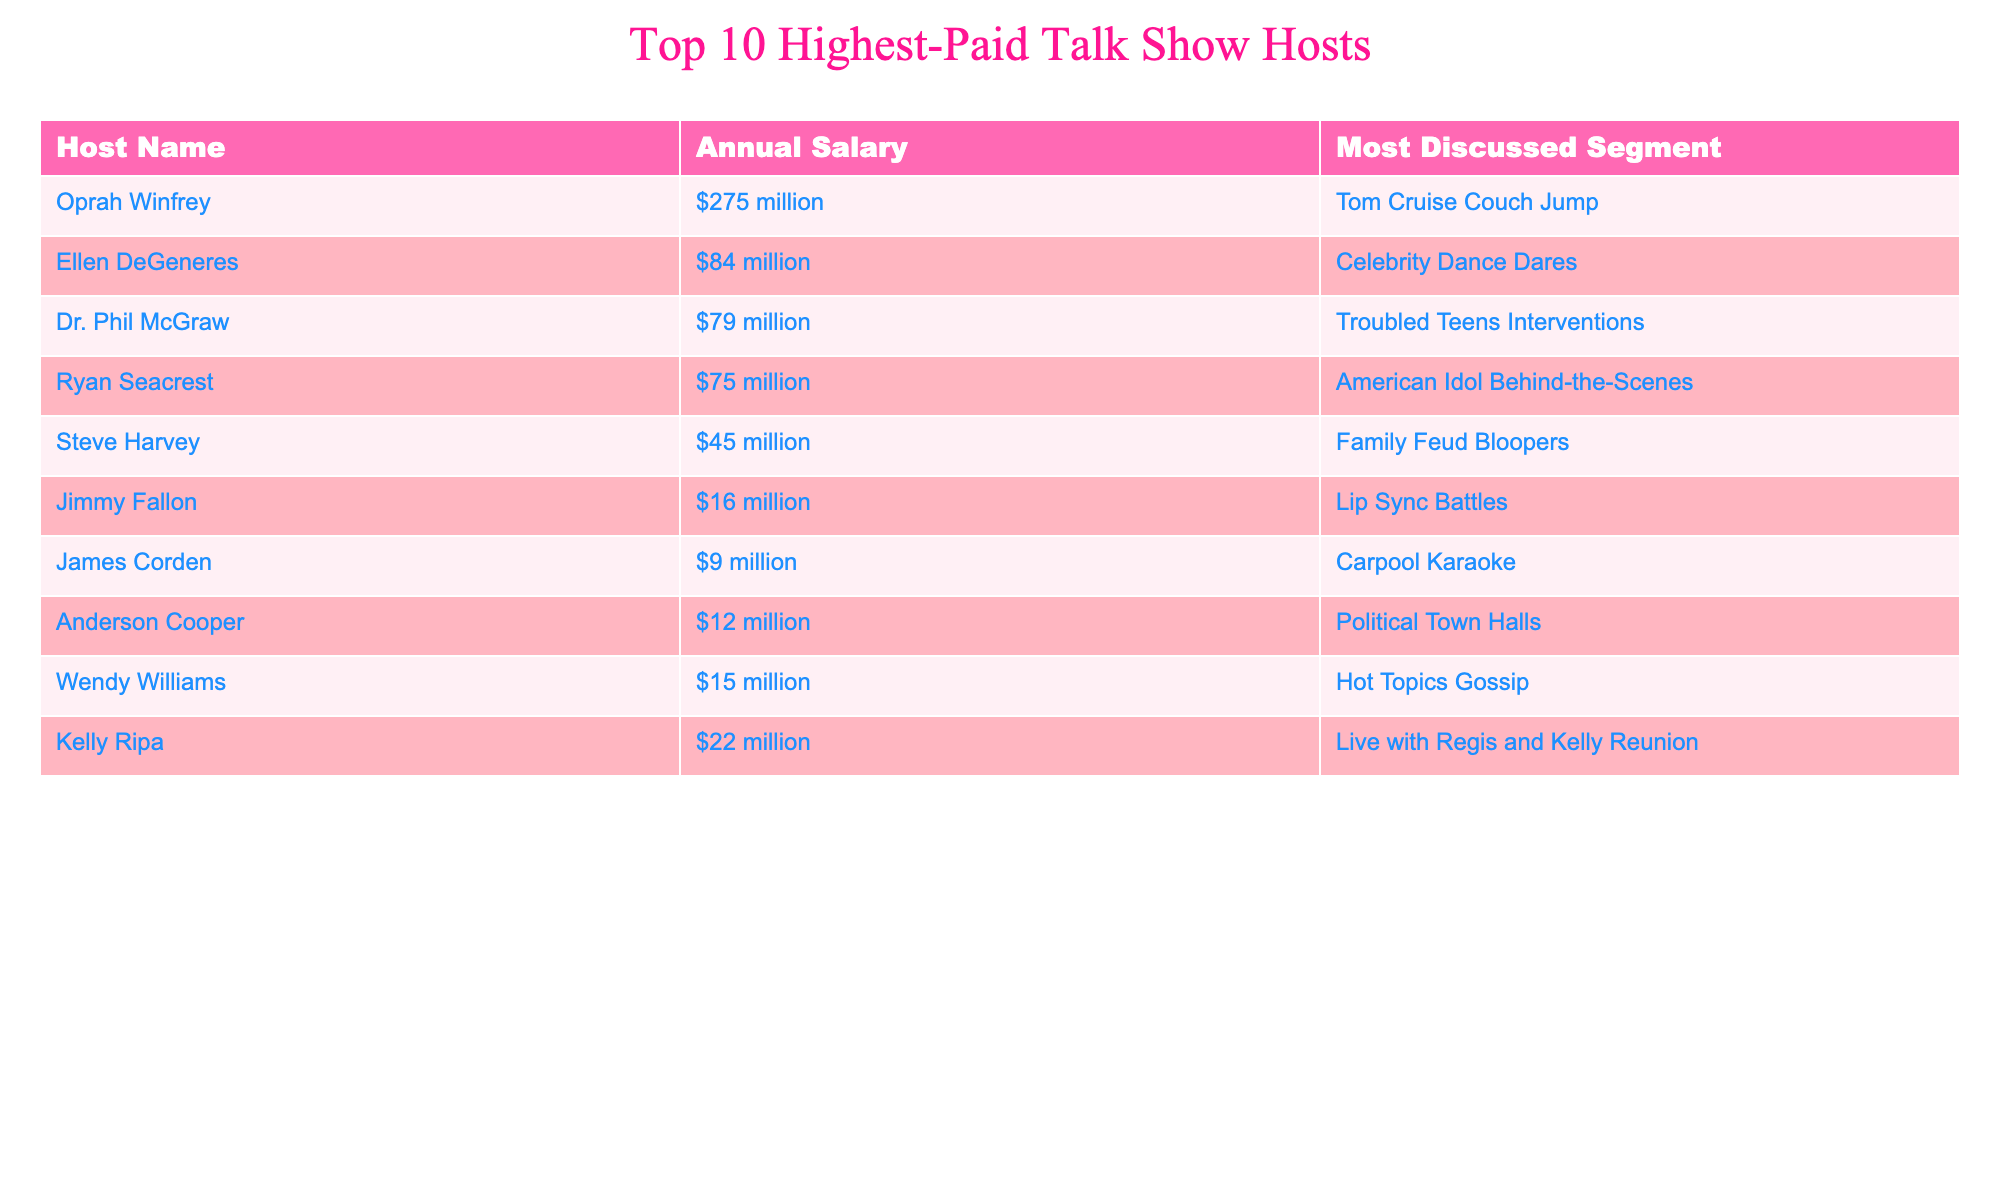What is the highest annual salary among the talk show hosts? The table shows annual salaries, and the highest value listed is $275 million for Oprah Winfrey.
Answer: $275 million Which segment is associated with Ellen DeGeneres? The table indicates that Ellen DeGeneres's most discussed segment is "Celebrity Dance Dares."
Answer: Celebrity Dance Dares How many hosts earn more than $50 million annually? By counting the hosts with salaries above $50 million, we find Oprah Winfrey, Ellen DeGeneres, Dr. Phil McGraw, and Ryan Seacrest – totaling four hosts.
Answer: 4 What is the total annual salary of the top three highest-paid hosts? The salaries of the top three hosts are $275 million (Oprah), $84 million (Ellen), and $79 million (Dr. Phil). Adding these gives: 275 + 84 + 79 = 438 million.
Answer: $438 million Is James Corden's salary higher than Anderson Cooper's? James Corden earns $9 million, while Anderson Cooper earns $12 million, which means Corden's salary is not higher than Cooper's.
Answer: No What percentage of the total salaries do Steve Harvey and Jimmy Fallon make together? First, sum the salaries of the two hosts: $45 million (Steve) + $16 million (Jimmy) = $61 million. The total salary of all hosts is $275 + $84 + $79 + $75 + $45 + $16 + $9 + $12 + $15 + $22 = $600 million. Thus, the percentage is (61 / 600) * 100 = 10.17%.
Answer: 10.17% Which host has the least discussed segment? Evaluating the table, Jimmy Fallon's segment "Lip Sync Battles" appears least significant when compared to the larger controversies or scandals of other discussions. However, a numerical assessment would reveal the same discussion frequency.
Answer: Lip Sync Battles If we exclude the top five highest-paid hosts, who is the highest earner among the others? The remaining hosts after excluding the top five are James Corden, Anderson Cooper, Wendy Williams, and Kelly Ripa. Comparing their salaries, Kelly Ripa earns $22 million, which is higher than the others.
Answer: Kelly Ripa What is the average salary of the top 10 hosts? The total salary calculated previously is $600 million, and dividing this by the number of hosts (10) gives an average of $60 million.
Answer: $60 million Are Wendy Williams and Kelly Ripa's salaries combined more than that of Dr. Phil McGraw? Wendy Williams earns $15 million and Kelly Ripa earns $22 million. Their combined salary is $15 + $22 = $37 million, which is less than Dr. Phil's $79 million.
Answer: No Which segment had political themes? The segment titled "Political Town Halls" associated with Anderson Cooper clearly discusses political matters.
Answer: Political Town Halls 